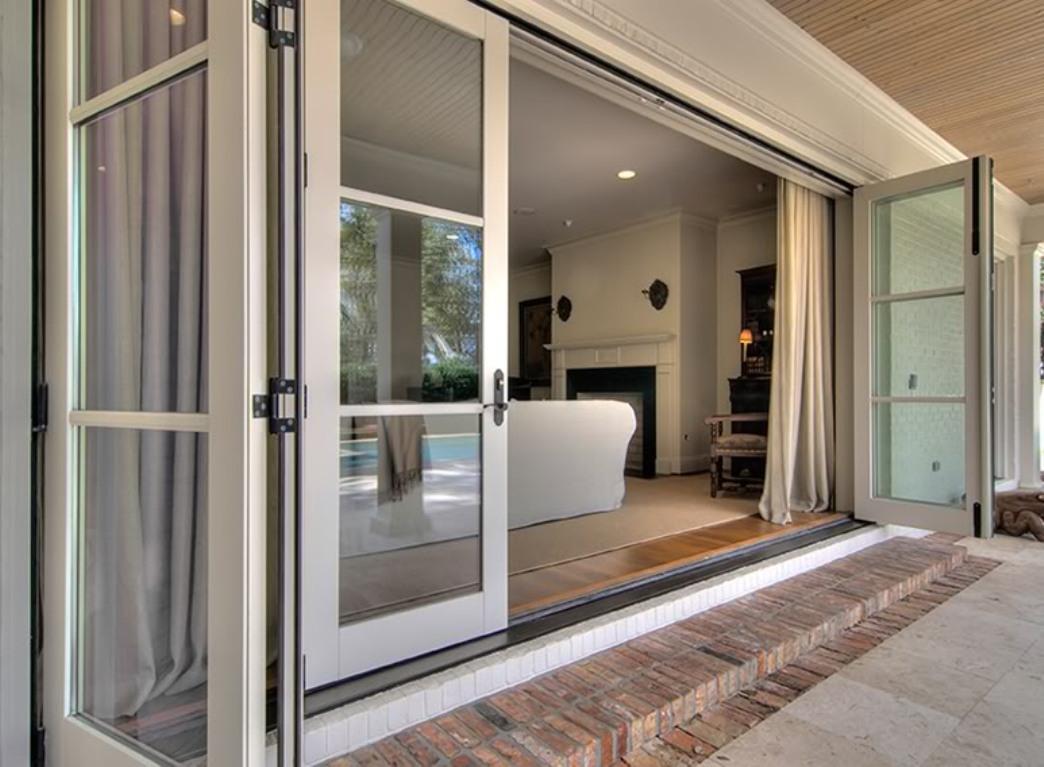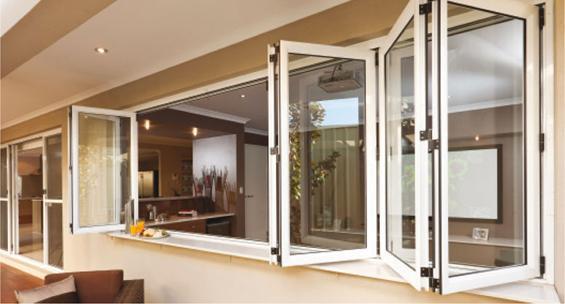The first image is the image on the left, the second image is the image on the right. Assess this claim about the two images: "An image shows a row of hinged glass panels forming an accordion-like pattern.". Correct or not? Answer yes or no. Yes. The first image is the image on the left, the second image is the image on the right. Given the left and right images, does the statement "Both sets of doors in the images are white." hold true? Answer yes or no. Yes. 